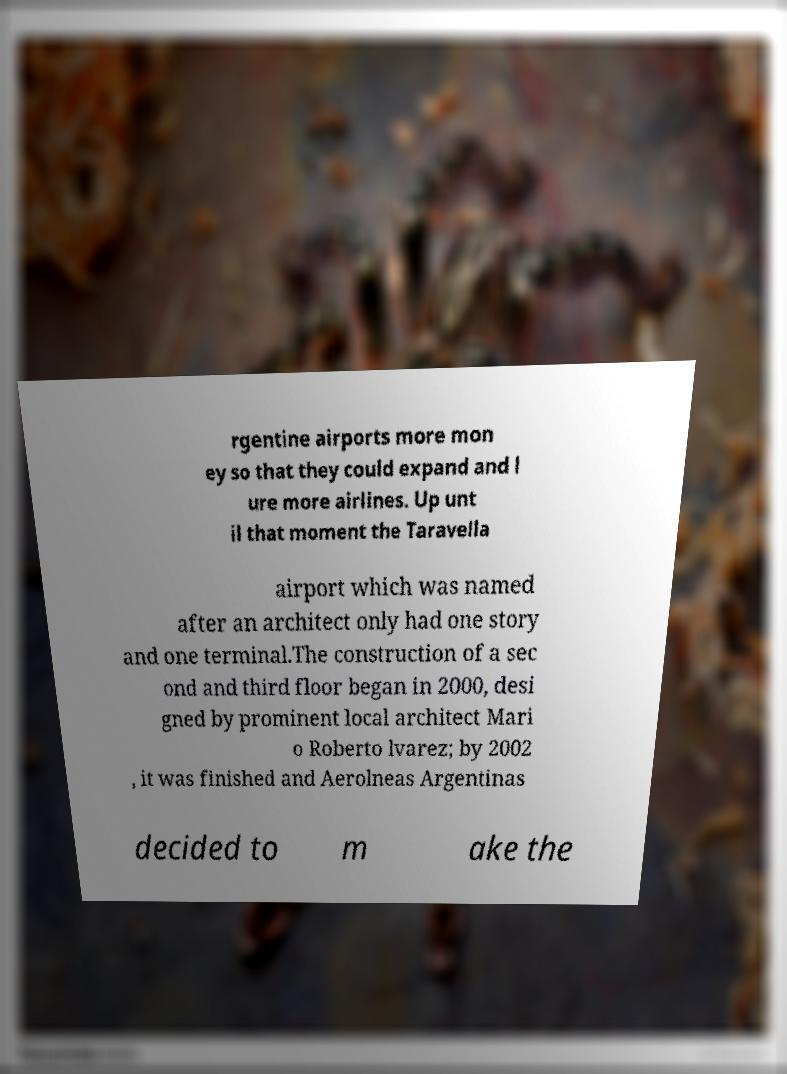Could you assist in decoding the text presented in this image and type it out clearly? rgentine airports more mon ey so that they could expand and l ure more airlines. Up unt il that moment the Taravella airport which was named after an architect only had one story and one terminal.The construction of a sec ond and third floor began in 2000, desi gned by prominent local architect Mari o Roberto lvarez; by 2002 , it was finished and Aerolneas Argentinas decided to m ake the 